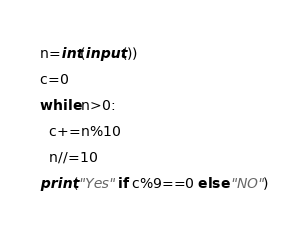Convert code to text. <code><loc_0><loc_0><loc_500><loc_500><_Python_>n=int(input())
c=0
while n>0:
  c+=n%10
  n//=10
print("Yes" if c%9==0 else "NO")</code> 